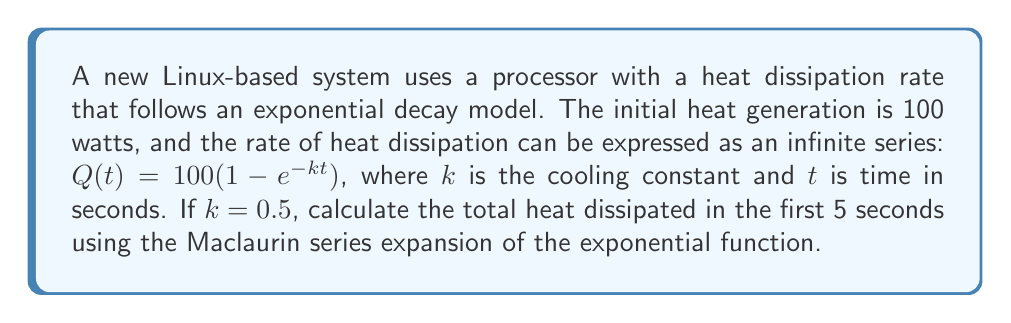Could you help me with this problem? 1) First, let's expand $e^{-kt}$ using the Maclaurin series:
   $$e^{-kt} = 1 - kt + \frac{(kt)^2}{2!} - \frac{(kt)^3}{3!} + \frac{(kt)^4}{4!} - \cdots$$

2) Substitute this into our heat dissipation function:
   $$Q(t) = 100(1 - (1 - kt + \frac{(kt)^2}{2!} - \frac{(kt)^3}{3!} + \frac{(kt)^4}{4!} - \cdots))$$

3) Simplify:
   $$Q(t) = 100(kt - \frac{(kt)^2}{2!} + \frac{(kt)^3}{3!} - \frac{(kt)^4}{4!} + \cdots)$$

4) Given $k = 0.5$ and $t = 5$, substitute these values:
   $$Q(5) = 100((0.5 \cdot 5) - \frac{(0.5 \cdot 5)^2}{2!} + \frac{(0.5 \cdot 5)^3}{3!} - \frac{(0.5 \cdot 5)^4}{4!} + \cdots)$$

5) Simplify:
   $$Q(5) = 100(2.5 - \frac{6.25}{2} + \frac{15.625}{6} - \frac{39.0625}{24} + \cdots)$$

6) Calculate the first few terms:
   $$Q(5) = 100(2.5 - 3.125 + 2.604 - 1.628 + \cdots)$$

7) Sum the terms:
   $$Q(5) \approx 100(0.351)$$

8) Final result:
   $$Q(5) \approx 35.1 \text{ watts}$$
Answer: 35.1 watts 